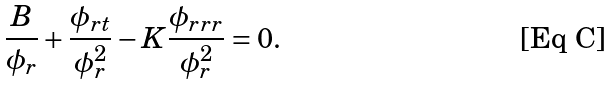Convert formula to latex. <formula><loc_0><loc_0><loc_500><loc_500>\frac { B } { \phi _ { r } } + \frac { \phi _ { r t } } { \phi _ { r } ^ { 2 } } - K \frac { \phi _ { r r r } } { \phi _ { r } ^ { 2 } } = 0 .</formula> 